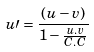<formula> <loc_0><loc_0><loc_500><loc_500>u \prime = \frac { ( u - v ) } { 1 - \frac { u . v } { C . C } }</formula> 